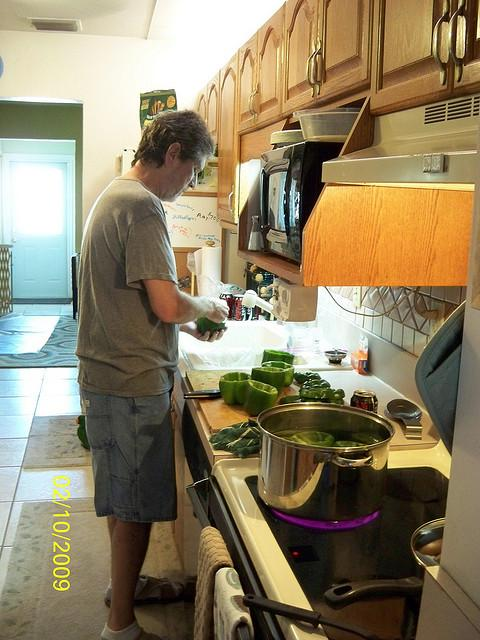What is the person cutting? peppers 